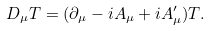Convert formula to latex. <formula><loc_0><loc_0><loc_500><loc_500>D _ { \mu } T = ( \partial _ { \mu } - i A _ { \mu } + i A _ { \mu } ^ { \prime } ) T .</formula> 